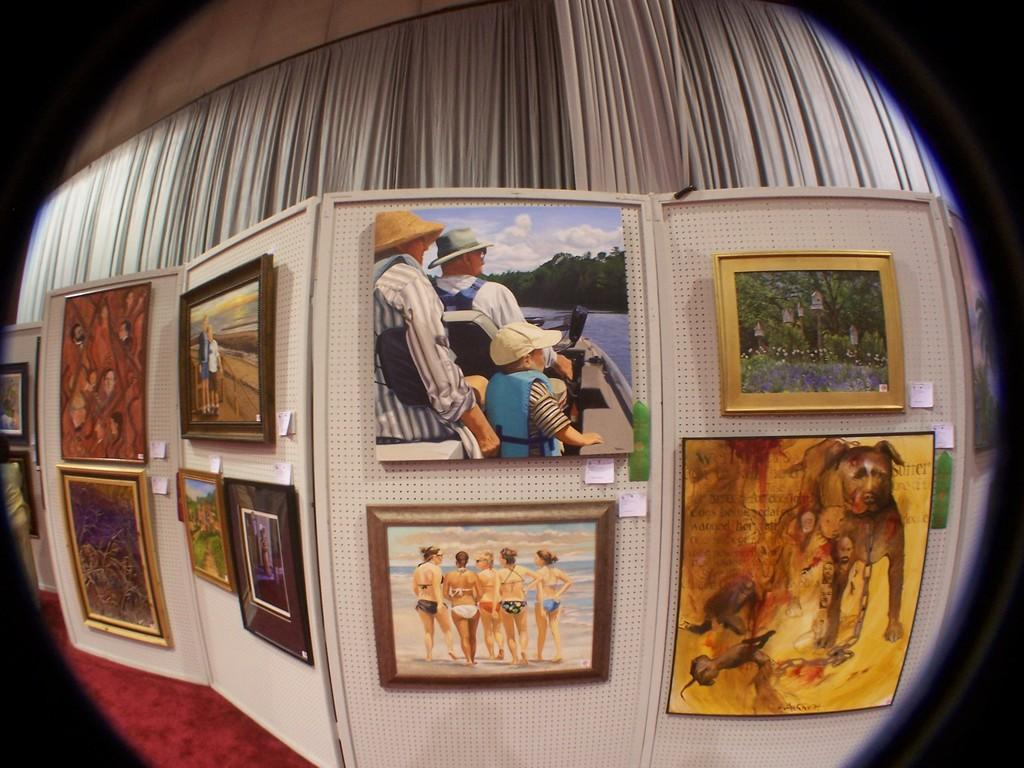What is the main subject of the image? The main subject of the image is many photo frames in the center. What can be seen in the background of the image? There is a curtain and a wall in the background of the image. How many caps are visible on the wall in the image? There are no caps visible on the wall in the image. What type of lead is being used to connect the photo frames in the image? There is no lead connecting the photo frames in the image. Can you see any cattle in the image? There are no cattle present in the image. 